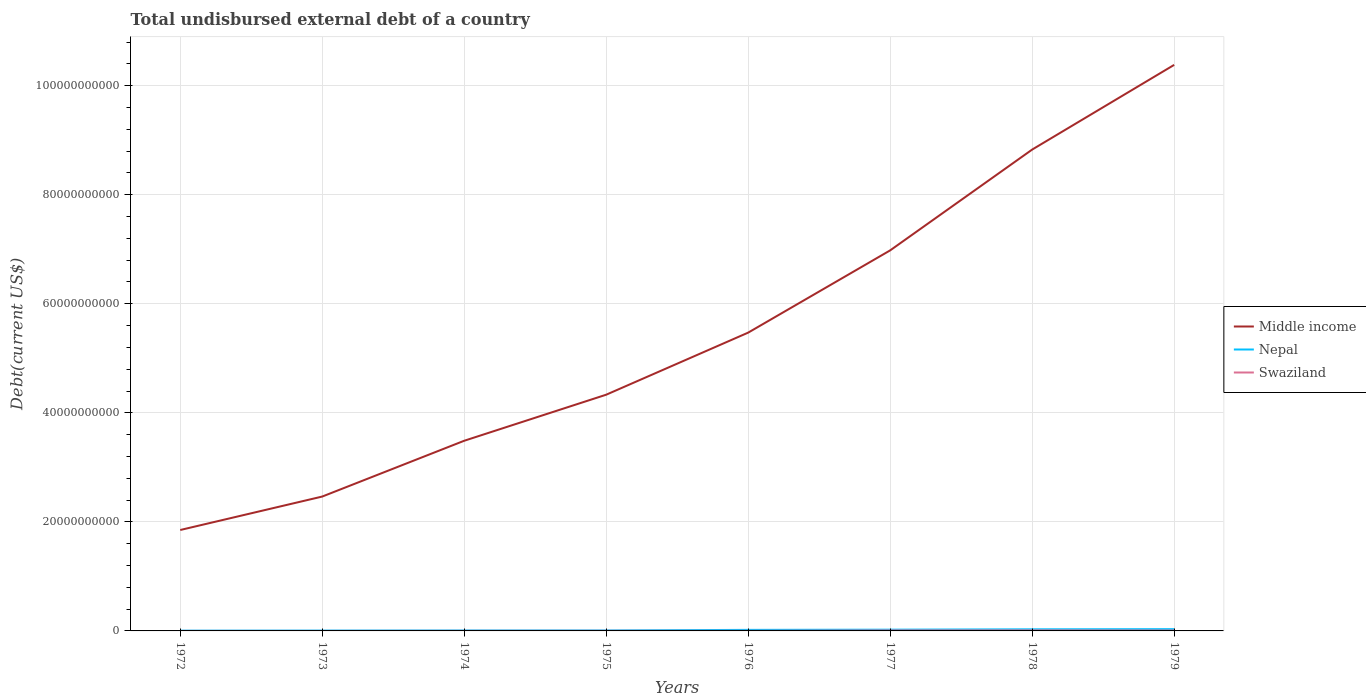Across all years, what is the maximum total undisbursed external debt in Middle income?
Give a very brief answer. 1.85e+1. What is the total total undisbursed external debt in Swaziland in the graph?
Your answer should be very brief. -7.01e+07. What is the difference between the highest and the second highest total undisbursed external debt in Nepal?
Keep it short and to the point. 2.76e+08. What is the difference between the highest and the lowest total undisbursed external debt in Middle income?
Ensure brevity in your answer.  3. Is the total undisbursed external debt in Swaziland strictly greater than the total undisbursed external debt in Nepal over the years?
Your answer should be compact. Yes. How many lines are there?
Give a very brief answer. 3. What is the difference between two consecutive major ticks on the Y-axis?
Your answer should be compact. 2.00e+1. Does the graph contain any zero values?
Ensure brevity in your answer.  No. Where does the legend appear in the graph?
Your response must be concise. Center right. How many legend labels are there?
Your answer should be compact. 3. What is the title of the graph?
Your response must be concise. Total undisbursed external debt of a country. Does "New Caledonia" appear as one of the legend labels in the graph?
Keep it short and to the point. No. What is the label or title of the Y-axis?
Offer a very short reply. Debt(current US$). What is the Debt(current US$) of Middle income in 1972?
Offer a very short reply. 1.85e+1. What is the Debt(current US$) of Nepal in 1972?
Offer a very short reply. 4.87e+07. What is the Debt(current US$) of Swaziland in 1972?
Your answer should be compact. 1.42e+06. What is the Debt(current US$) in Middle income in 1973?
Ensure brevity in your answer.  2.46e+1. What is the Debt(current US$) of Nepal in 1973?
Provide a succinct answer. 6.23e+07. What is the Debt(current US$) in Swaziland in 1973?
Provide a succinct answer. 2.10e+06. What is the Debt(current US$) of Middle income in 1974?
Your response must be concise. 3.49e+1. What is the Debt(current US$) in Nepal in 1974?
Give a very brief answer. 8.11e+07. What is the Debt(current US$) of Swaziland in 1974?
Keep it short and to the point. 1.30e+07. What is the Debt(current US$) in Middle income in 1975?
Your response must be concise. 4.33e+1. What is the Debt(current US$) in Nepal in 1975?
Your response must be concise. 8.62e+07. What is the Debt(current US$) in Swaziland in 1975?
Give a very brief answer. 2.20e+07. What is the Debt(current US$) of Middle income in 1976?
Your answer should be very brief. 5.47e+1. What is the Debt(current US$) in Nepal in 1976?
Make the answer very short. 1.92e+08. What is the Debt(current US$) in Swaziland in 1976?
Provide a succinct answer. 1.75e+07. What is the Debt(current US$) in Middle income in 1977?
Give a very brief answer. 6.98e+1. What is the Debt(current US$) in Nepal in 1977?
Provide a succinct answer. 2.28e+08. What is the Debt(current US$) in Swaziland in 1977?
Provide a succinct answer. 8.31e+07. What is the Debt(current US$) of Middle income in 1978?
Provide a short and direct response. 8.83e+1. What is the Debt(current US$) of Nepal in 1978?
Make the answer very short. 2.94e+08. What is the Debt(current US$) of Swaziland in 1978?
Your answer should be compact. 9.63e+07. What is the Debt(current US$) in Middle income in 1979?
Your response must be concise. 1.04e+11. What is the Debt(current US$) of Nepal in 1979?
Offer a very short reply. 3.24e+08. What is the Debt(current US$) in Swaziland in 1979?
Your response must be concise. 7.16e+07. Across all years, what is the maximum Debt(current US$) of Middle income?
Give a very brief answer. 1.04e+11. Across all years, what is the maximum Debt(current US$) in Nepal?
Keep it short and to the point. 3.24e+08. Across all years, what is the maximum Debt(current US$) in Swaziland?
Make the answer very short. 9.63e+07. Across all years, what is the minimum Debt(current US$) of Middle income?
Provide a succinct answer. 1.85e+1. Across all years, what is the minimum Debt(current US$) in Nepal?
Offer a terse response. 4.87e+07. Across all years, what is the minimum Debt(current US$) in Swaziland?
Offer a terse response. 1.42e+06. What is the total Debt(current US$) in Middle income in the graph?
Make the answer very short. 4.38e+11. What is the total Debt(current US$) in Nepal in the graph?
Provide a short and direct response. 1.32e+09. What is the total Debt(current US$) of Swaziland in the graph?
Your response must be concise. 3.07e+08. What is the difference between the Debt(current US$) in Middle income in 1972 and that in 1973?
Keep it short and to the point. -6.13e+09. What is the difference between the Debt(current US$) in Nepal in 1972 and that in 1973?
Offer a terse response. -1.37e+07. What is the difference between the Debt(current US$) of Swaziland in 1972 and that in 1973?
Your response must be concise. -6.87e+05. What is the difference between the Debt(current US$) of Middle income in 1972 and that in 1974?
Make the answer very short. -1.64e+1. What is the difference between the Debt(current US$) of Nepal in 1972 and that in 1974?
Your response must be concise. -3.25e+07. What is the difference between the Debt(current US$) in Swaziland in 1972 and that in 1974?
Offer a very short reply. -1.16e+07. What is the difference between the Debt(current US$) of Middle income in 1972 and that in 1975?
Your response must be concise. -2.48e+1. What is the difference between the Debt(current US$) of Nepal in 1972 and that in 1975?
Give a very brief answer. -3.76e+07. What is the difference between the Debt(current US$) of Swaziland in 1972 and that in 1975?
Ensure brevity in your answer.  -2.06e+07. What is the difference between the Debt(current US$) of Middle income in 1972 and that in 1976?
Give a very brief answer. -3.62e+1. What is the difference between the Debt(current US$) of Nepal in 1972 and that in 1976?
Offer a very short reply. -1.44e+08. What is the difference between the Debt(current US$) of Swaziland in 1972 and that in 1976?
Provide a succinct answer. -1.61e+07. What is the difference between the Debt(current US$) of Middle income in 1972 and that in 1977?
Offer a very short reply. -5.13e+1. What is the difference between the Debt(current US$) in Nepal in 1972 and that in 1977?
Your response must be concise. -1.80e+08. What is the difference between the Debt(current US$) in Swaziland in 1972 and that in 1977?
Make the answer very short. -8.17e+07. What is the difference between the Debt(current US$) of Middle income in 1972 and that in 1978?
Your answer should be very brief. -6.98e+1. What is the difference between the Debt(current US$) in Nepal in 1972 and that in 1978?
Your answer should be very brief. -2.46e+08. What is the difference between the Debt(current US$) in Swaziland in 1972 and that in 1978?
Your answer should be compact. -9.49e+07. What is the difference between the Debt(current US$) in Middle income in 1972 and that in 1979?
Give a very brief answer. -8.53e+1. What is the difference between the Debt(current US$) in Nepal in 1972 and that in 1979?
Ensure brevity in your answer.  -2.76e+08. What is the difference between the Debt(current US$) in Swaziland in 1972 and that in 1979?
Your answer should be very brief. -7.02e+07. What is the difference between the Debt(current US$) of Middle income in 1973 and that in 1974?
Keep it short and to the point. -1.02e+1. What is the difference between the Debt(current US$) in Nepal in 1973 and that in 1974?
Give a very brief answer. -1.88e+07. What is the difference between the Debt(current US$) in Swaziland in 1973 and that in 1974?
Ensure brevity in your answer.  -1.09e+07. What is the difference between the Debt(current US$) in Middle income in 1973 and that in 1975?
Give a very brief answer. -1.87e+1. What is the difference between the Debt(current US$) in Nepal in 1973 and that in 1975?
Your response must be concise. -2.39e+07. What is the difference between the Debt(current US$) of Swaziland in 1973 and that in 1975?
Offer a very short reply. -1.99e+07. What is the difference between the Debt(current US$) of Middle income in 1973 and that in 1976?
Offer a terse response. -3.01e+1. What is the difference between the Debt(current US$) in Nepal in 1973 and that in 1976?
Provide a succinct answer. -1.30e+08. What is the difference between the Debt(current US$) in Swaziland in 1973 and that in 1976?
Give a very brief answer. -1.54e+07. What is the difference between the Debt(current US$) of Middle income in 1973 and that in 1977?
Give a very brief answer. -4.52e+1. What is the difference between the Debt(current US$) of Nepal in 1973 and that in 1977?
Give a very brief answer. -1.66e+08. What is the difference between the Debt(current US$) of Swaziland in 1973 and that in 1977?
Offer a terse response. -8.10e+07. What is the difference between the Debt(current US$) in Middle income in 1973 and that in 1978?
Your answer should be compact. -6.36e+1. What is the difference between the Debt(current US$) of Nepal in 1973 and that in 1978?
Your answer should be very brief. -2.32e+08. What is the difference between the Debt(current US$) in Swaziland in 1973 and that in 1978?
Ensure brevity in your answer.  -9.42e+07. What is the difference between the Debt(current US$) in Middle income in 1973 and that in 1979?
Provide a short and direct response. -7.92e+1. What is the difference between the Debt(current US$) in Nepal in 1973 and that in 1979?
Keep it short and to the point. -2.62e+08. What is the difference between the Debt(current US$) of Swaziland in 1973 and that in 1979?
Make the answer very short. -6.95e+07. What is the difference between the Debt(current US$) in Middle income in 1974 and that in 1975?
Provide a short and direct response. -8.45e+09. What is the difference between the Debt(current US$) in Nepal in 1974 and that in 1975?
Give a very brief answer. -5.09e+06. What is the difference between the Debt(current US$) of Swaziland in 1974 and that in 1975?
Offer a terse response. -8.95e+06. What is the difference between the Debt(current US$) of Middle income in 1974 and that in 1976?
Give a very brief answer. -1.98e+1. What is the difference between the Debt(current US$) of Nepal in 1974 and that in 1976?
Your answer should be compact. -1.11e+08. What is the difference between the Debt(current US$) of Swaziland in 1974 and that in 1976?
Offer a terse response. -4.43e+06. What is the difference between the Debt(current US$) in Middle income in 1974 and that in 1977?
Ensure brevity in your answer.  -3.49e+1. What is the difference between the Debt(current US$) in Nepal in 1974 and that in 1977?
Offer a terse response. -1.47e+08. What is the difference between the Debt(current US$) in Swaziland in 1974 and that in 1977?
Keep it short and to the point. -7.01e+07. What is the difference between the Debt(current US$) in Middle income in 1974 and that in 1978?
Give a very brief answer. -5.34e+1. What is the difference between the Debt(current US$) in Nepal in 1974 and that in 1978?
Offer a very short reply. -2.13e+08. What is the difference between the Debt(current US$) in Swaziland in 1974 and that in 1978?
Give a very brief answer. -8.33e+07. What is the difference between the Debt(current US$) of Middle income in 1974 and that in 1979?
Provide a succinct answer. -6.89e+1. What is the difference between the Debt(current US$) in Nepal in 1974 and that in 1979?
Provide a succinct answer. -2.43e+08. What is the difference between the Debt(current US$) in Swaziland in 1974 and that in 1979?
Make the answer very short. -5.86e+07. What is the difference between the Debt(current US$) in Middle income in 1975 and that in 1976?
Your response must be concise. -1.14e+1. What is the difference between the Debt(current US$) in Nepal in 1975 and that in 1976?
Give a very brief answer. -1.06e+08. What is the difference between the Debt(current US$) of Swaziland in 1975 and that in 1976?
Offer a very short reply. 4.52e+06. What is the difference between the Debt(current US$) of Middle income in 1975 and that in 1977?
Offer a very short reply. -2.65e+1. What is the difference between the Debt(current US$) of Nepal in 1975 and that in 1977?
Give a very brief answer. -1.42e+08. What is the difference between the Debt(current US$) in Swaziland in 1975 and that in 1977?
Provide a succinct answer. -6.11e+07. What is the difference between the Debt(current US$) in Middle income in 1975 and that in 1978?
Offer a terse response. -4.50e+1. What is the difference between the Debt(current US$) of Nepal in 1975 and that in 1978?
Keep it short and to the point. -2.08e+08. What is the difference between the Debt(current US$) in Swaziland in 1975 and that in 1978?
Your response must be concise. -7.43e+07. What is the difference between the Debt(current US$) in Middle income in 1975 and that in 1979?
Provide a succinct answer. -6.05e+1. What is the difference between the Debt(current US$) of Nepal in 1975 and that in 1979?
Offer a terse response. -2.38e+08. What is the difference between the Debt(current US$) of Swaziland in 1975 and that in 1979?
Provide a succinct answer. -4.96e+07. What is the difference between the Debt(current US$) in Middle income in 1976 and that in 1977?
Give a very brief answer. -1.51e+1. What is the difference between the Debt(current US$) of Nepal in 1976 and that in 1977?
Offer a terse response. -3.63e+07. What is the difference between the Debt(current US$) in Swaziland in 1976 and that in 1977?
Provide a short and direct response. -6.56e+07. What is the difference between the Debt(current US$) of Middle income in 1976 and that in 1978?
Keep it short and to the point. -3.36e+1. What is the difference between the Debt(current US$) of Nepal in 1976 and that in 1978?
Your answer should be compact. -1.02e+08. What is the difference between the Debt(current US$) in Swaziland in 1976 and that in 1978?
Ensure brevity in your answer.  -7.88e+07. What is the difference between the Debt(current US$) in Middle income in 1976 and that in 1979?
Your answer should be very brief. -4.91e+1. What is the difference between the Debt(current US$) of Nepal in 1976 and that in 1979?
Give a very brief answer. -1.32e+08. What is the difference between the Debt(current US$) of Swaziland in 1976 and that in 1979?
Your response must be concise. -5.42e+07. What is the difference between the Debt(current US$) of Middle income in 1977 and that in 1978?
Ensure brevity in your answer.  -1.85e+1. What is the difference between the Debt(current US$) of Nepal in 1977 and that in 1978?
Give a very brief answer. -6.57e+07. What is the difference between the Debt(current US$) of Swaziland in 1977 and that in 1978?
Offer a very short reply. -1.32e+07. What is the difference between the Debt(current US$) of Middle income in 1977 and that in 1979?
Offer a very short reply. -3.40e+1. What is the difference between the Debt(current US$) in Nepal in 1977 and that in 1979?
Keep it short and to the point. -9.57e+07. What is the difference between the Debt(current US$) in Swaziland in 1977 and that in 1979?
Your response must be concise. 1.15e+07. What is the difference between the Debt(current US$) of Middle income in 1978 and that in 1979?
Give a very brief answer. -1.55e+1. What is the difference between the Debt(current US$) in Nepal in 1978 and that in 1979?
Give a very brief answer. -3.00e+07. What is the difference between the Debt(current US$) in Swaziland in 1978 and that in 1979?
Provide a succinct answer. 2.47e+07. What is the difference between the Debt(current US$) of Middle income in 1972 and the Debt(current US$) of Nepal in 1973?
Make the answer very short. 1.84e+1. What is the difference between the Debt(current US$) in Middle income in 1972 and the Debt(current US$) in Swaziland in 1973?
Provide a short and direct response. 1.85e+1. What is the difference between the Debt(current US$) of Nepal in 1972 and the Debt(current US$) of Swaziland in 1973?
Your answer should be very brief. 4.66e+07. What is the difference between the Debt(current US$) in Middle income in 1972 and the Debt(current US$) in Nepal in 1974?
Your answer should be compact. 1.84e+1. What is the difference between the Debt(current US$) of Middle income in 1972 and the Debt(current US$) of Swaziland in 1974?
Your answer should be very brief. 1.85e+1. What is the difference between the Debt(current US$) in Nepal in 1972 and the Debt(current US$) in Swaziland in 1974?
Your answer should be compact. 3.56e+07. What is the difference between the Debt(current US$) in Middle income in 1972 and the Debt(current US$) in Nepal in 1975?
Keep it short and to the point. 1.84e+1. What is the difference between the Debt(current US$) in Middle income in 1972 and the Debt(current US$) in Swaziland in 1975?
Give a very brief answer. 1.85e+1. What is the difference between the Debt(current US$) in Nepal in 1972 and the Debt(current US$) in Swaziland in 1975?
Your response must be concise. 2.67e+07. What is the difference between the Debt(current US$) of Middle income in 1972 and the Debt(current US$) of Nepal in 1976?
Provide a succinct answer. 1.83e+1. What is the difference between the Debt(current US$) of Middle income in 1972 and the Debt(current US$) of Swaziland in 1976?
Provide a succinct answer. 1.85e+1. What is the difference between the Debt(current US$) in Nepal in 1972 and the Debt(current US$) in Swaziland in 1976?
Provide a succinct answer. 3.12e+07. What is the difference between the Debt(current US$) of Middle income in 1972 and the Debt(current US$) of Nepal in 1977?
Provide a short and direct response. 1.83e+1. What is the difference between the Debt(current US$) of Middle income in 1972 and the Debt(current US$) of Swaziland in 1977?
Your response must be concise. 1.84e+1. What is the difference between the Debt(current US$) of Nepal in 1972 and the Debt(current US$) of Swaziland in 1977?
Your answer should be very brief. -3.44e+07. What is the difference between the Debt(current US$) of Middle income in 1972 and the Debt(current US$) of Nepal in 1978?
Give a very brief answer. 1.82e+1. What is the difference between the Debt(current US$) of Middle income in 1972 and the Debt(current US$) of Swaziland in 1978?
Your response must be concise. 1.84e+1. What is the difference between the Debt(current US$) in Nepal in 1972 and the Debt(current US$) in Swaziland in 1978?
Offer a very short reply. -4.76e+07. What is the difference between the Debt(current US$) in Middle income in 1972 and the Debt(current US$) in Nepal in 1979?
Your answer should be very brief. 1.82e+1. What is the difference between the Debt(current US$) in Middle income in 1972 and the Debt(current US$) in Swaziland in 1979?
Your answer should be very brief. 1.84e+1. What is the difference between the Debt(current US$) of Nepal in 1972 and the Debt(current US$) of Swaziland in 1979?
Provide a succinct answer. -2.30e+07. What is the difference between the Debt(current US$) of Middle income in 1973 and the Debt(current US$) of Nepal in 1974?
Ensure brevity in your answer.  2.46e+1. What is the difference between the Debt(current US$) of Middle income in 1973 and the Debt(current US$) of Swaziland in 1974?
Provide a succinct answer. 2.46e+1. What is the difference between the Debt(current US$) in Nepal in 1973 and the Debt(current US$) in Swaziland in 1974?
Ensure brevity in your answer.  4.93e+07. What is the difference between the Debt(current US$) of Middle income in 1973 and the Debt(current US$) of Nepal in 1975?
Your answer should be compact. 2.46e+1. What is the difference between the Debt(current US$) of Middle income in 1973 and the Debt(current US$) of Swaziland in 1975?
Make the answer very short. 2.46e+1. What is the difference between the Debt(current US$) of Nepal in 1973 and the Debt(current US$) of Swaziland in 1975?
Offer a terse response. 4.04e+07. What is the difference between the Debt(current US$) of Middle income in 1973 and the Debt(current US$) of Nepal in 1976?
Ensure brevity in your answer.  2.44e+1. What is the difference between the Debt(current US$) in Middle income in 1973 and the Debt(current US$) in Swaziland in 1976?
Provide a short and direct response. 2.46e+1. What is the difference between the Debt(current US$) of Nepal in 1973 and the Debt(current US$) of Swaziland in 1976?
Offer a terse response. 4.49e+07. What is the difference between the Debt(current US$) in Middle income in 1973 and the Debt(current US$) in Nepal in 1977?
Keep it short and to the point. 2.44e+1. What is the difference between the Debt(current US$) in Middle income in 1973 and the Debt(current US$) in Swaziland in 1977?
Offer a very short reply. 2.46e+1. What is the difference between the Debt(current US$) of Nepal in 1973 and the Debt(current US$) of Swaziland in 1977?
Ensure brevity in your answer.  -2.08e+07. What is the difference between the Debt(current US$) of Middle income in 1973 and the Debt(current US$) of Nepal in 1978?
Your answer should be very brief. 2.43e+1. What is the difference between the Debt(current US$) of Middle income in 1973 and the Debt(current US$) of Swaziland in 1978?
Make the answer very short. 2.45e+1. What is the difference between the Debt(current US$) of Nepal in 1973 and the Debt(current US$) of Swaziland in 1978?
Provide a succinct answer. -3.40e+07. What is the difference between the Debt(current US$) in Middle income in 1973 and the Debt(current US$) in Nepal in 1979?
Your response must be concise. 2.43e+1. What is the difference between the Debt(current US$) in Middle income in 1973 and the Debt(current US$) in Swaziland in 1979?
Keep it short and to the point. 2.46e+1. What is the difference between the Debt(current US$) of Nepal in 1973 and the Debt(current US$) of Swaziland in 1979?
Provide a short and direct response. -9.28e+06. What is the difference between the Debt(current US$) of Middle income in 1974 and the Debt(current US$) of Nepal in 1975?
Make the answer very short. 3.48e+1. What is the difference between the Debt(current US$) in Middle income in 1974 and the Debt(current US$) in Swaziland in 1975?
Your response must be concise. 3.49e+1. What is the difference between the Debt(current US$) of Nepal in 1974 and the Debt(current US$) of Swaziland in 1975?
Provide a short and direct response. 5.92e+07. What is the difference between the Debt(current US$) in Middle income in 1974 and the Debt(current US$) in Nepal in 1976?
Provide a short and direct response. 3.47e+1. What is the difference between the Debt(current US$) of Middle income in 1974 and the Debt(current US$) of Swaziland in 1976?
Ensure brevity in your answer.  3.49e+1. What is the difference between the Debt(current US$) in Nepal in 1974 and the Debt(current US$) in Swaziland in 1976?
Your response must be concise. 6.37e+07. What is the difference between the Debt(current US$) of Middle income in 1974 and the Debt(current US$) of Nepal in 1977?
Provide a succinct answer. 3.46e+1. What is the difference between the Debt(current US$) of Middle income in 1974 and the Debt(current US$) of Swaziland in 1977?
Make the answer very short. 3.48e+1. What is the difference between the Debt(current US$) in Nepal in 1974 and the Debt(current US$) in Swaziland in 1977?
Keep it short and to the point. -1.96e+06. What is the difference between the Debt(current US$) of Middle income in 1974 and the Debt(current US$) of Nepal in 1978?
Provide a short and direct response. 3.46e+1. What is the difference between the Debt(current US$) in Middle income in 1974 and the Debt(current US$) in Swaziland in 1978?
Offer a terse response. 3.48e+1. What is the difference between the Debt(current US$) of Nepal in 1974 and the Debt(current US$) of Swaziland in 1978?
Your answer should be very brief. -1.52e+07. What is the difference between the Debt(current US$) of Middle income in 1974 and the Debt(current US$) of Nepal in 1979?
Keep it short and to the point. 3.46e+1. What is the difference between the Debt(current US$) of Middle income in 1974 and the Debt(current US$) of Swaziland in 1979?
Provide a succinct answer. 3.48e+1. What is the difference between the Debt(current US$) in Nepal in 1974 and the Debt(current US$) in Swaziland in 1979?
Provide a short and direct response. 9.51e+06. What is the difference between the Debt(current US$) in Middle income in 1975 and the Debt(current US$) in Nepal in 1976?
Your answer should be compact. 4.31e+1. What is the difference between the Debt(current US$) in Middle income in 1975 and the Debt(current US$) in Swaziland in 1976?
Offer a terse response. 4.33e+1. What is the difference between the Debt(current US$) in Nepal in 1975 and the Debt(current US$) in Swaziland in 1976?
Provide a short and direct response. 6.88e+07. What is the difference between the Debt(current US$) of Middle income in 1975 and the Debt(current US$) of Nepal in 1977?
Your answer should be compact. 4.31e+1. What is the difference between the Debt(current US$) of Middle income in 1975 and the Debt(current US$) of Swaziland in 1977?
Make the answer very short. 4.32e+1. What is the difference between the Debt(current US$) in Nepal in 1975 and the Debt(current US$) in Swaziland in 1977?
Provide a short and direct response. 3.12e+06. What is the difference between the Debt(current US$) of Middle income in 1975 and the Debt(current US$) of Nepal in 1978?
Give a very brief answer. 4.30e+1. What is the difference between the Debt(current US$) in Middle income in 1975 and the Debt(current US$) in Swaziland in 1978?
Offer a terse response. 4.32e+1. What is the difference between the Debt(current US$) in Nepal in 1975 and the Debt(current US$) in Swaziland in 1978?
Your response must be concise. -1.01e+07. What is the difference between the Debt(current US$) in Middle income in 1975 and the Debt(current US$) in Nepal in 1979?
Provide a succinct answer. 4.30e+1. What is the difference between the Debt(current US$) of Middle income in 1975 and the Debt(current US$) of Swaziland in 1979?
Your answer should be very brief. 4.33e+1. What is the difference between the Debt(current US$) in Nepal in 1975 and the Debt(current US$) in Swaziland in 1979?
Provide a short and direct response. 1.46e+07. What is the difference between the Debt(current US$) of Middle income in 1976 and the Debt(current US$) of Nepal in 1977?
Your answer should be very brief. 5.45e+1. What is the difference between the Debt(current US$) in Middle income in 1976 and the Debt(current US$) in Swaziland in 1977?
Your answer should be very brief. 5.46e+1. What is the difference between the Debt(current US$) of Nepal in 1976 and the Debt(current US$) of Swaziland in 1977?
Ensure brevity in your answer.  1.09e+08. What is the difference between the Debt(current US$) of Middle income in 1976 and the Debt(current US$) of Nepal in 1978?
Ensure brevity in your answer.  5.44e+1. What is the difference between the Debt(current US$) in Middle income in 1976 and the Debt(current US$) in Swaziland in 1978?
Offer a terse response. 5.46e+1. What is the difference between the Debt(current US$) in Nepal in 1976 and the Debt(current US$) in Swaziland in 1978?
Give a very brief answer. 9.59e+07. What is the difference between the Debt(current US$) of Middle income in 1976 and the Debt(current US$) of Nepal in 1979?
Provide a succinct answer. 5.44e+1. What is the difference between the Debt(current US$) in Middle income in 1976 and the Debt(current US$) in Swaziland in 1979?
Keep it short and to the point. 5.46e+1. What is the difference between the Debt(current US$) in Nepal in 1976 and the Debt(current US$) in Swaziland in 1979?
Offer a very short reply. 1.21e+08. What is the difference between the Debt(current US$) of Middle income in 1977 and the Debt(current US$) of Nepal in 1978?
Offer a terse response. 6.95e+1. What is the difference between the Debt(current US$) of Middle income in 1977 and the Debt(current US$) of Swaziland in 1978?
Offer a terse response. 6.97e+1. What is the difference between the Debt(current US$) in Nepal in 1977 and the Debt(current US$) in Swaziland in 1978?
Offer a terse response. 1.32e+08. What is the difference between the Debt(current US$) of Middle income in 1977 and the Debt(current US$) of Nepal in 1979?
Give a very brief answer. 6.95e+1. What is the difference between the Debt(current US$) in Middle income in 1977 and the Debt(current US$) in Swaziland in 1979?
Offer a very short reply. 6.97e+1. What is the difference between the Debt(current US$) in Nepal in 1977 and the Debt(current US$) in Swaziland in 1979?
Offer a terse response. 1.57e+08. What is the difference between the Debt(current US$) of Middle income in 1978 and the Debt(current US$) of Nepal in 1979?
Provide a succinct answer. 8.80e+1. What is the difference between the Debt(current US$) in Middle income in 1978 and the Debt(current US$) in Swaziland in 1979?
Give a very brief answer. 8.82e+1. What is the difference between the Debt(current US$) of Nepal in 1978 and the Debt(current US$) of Swaziland in 1979?
Ensure brevity in your answer.  2.23e+08. What is the average Debt(current US$) in Middle income per year?
Your answer should be very brief. 5.47e+1. What is the average Debt(current US$) in Nepal per year?
Provide a succinct answer. 1.65e+08. What is the average Debt(current US$) in Swaziland per year?
Give a very brief answer. 3.84e+07. In the year 1972, what is the difference between the Debt(current US$) in Middle income and Debt(current US$) in Nepal?
Your answer should be compact. 1.85e+1. In the year 1972, what is the difference between the Debt(current US$) in Middle income and Debt(current US$) in Swaziland?
Give a very brief answer. 1.85e+1. In the year 1972, what is the difference between the Debt(current US$) in Nepal and Debt(current US$) in Swaziland?
Offer a very short reply. 4.72e+07. In the year 1973, what is the difference between the Debt(current US$) of Middle income and Debt(current US$) of Nepal?
Give a very brief answer. 2.46e+1. In the year 1973, what is the difference between the Debt(current US$) in Middle income and Debt(current US$) in Swaziland?
Your answer should be compact. 2.46e+1. In the year 1973, what is the difference between the Debt(current US$) in Nepal and Debt(current US$) in Swaziland?
Your answer should be very brief. 6.02e+07. In the year 1974, what is the difference between the Debt(current US$) of Middle income and Debt(current US$) of Nepal?
Offer a terse response. 3.48e+1. In the year 1974, what is the difference between the Debt(current US$) in Middle income and Debt(current US$) in Swaziland?
Your answer should be very brief. 3.49e+1. In the year 1974, what is the difference between the Debt(current US$) in Nepal and Debt(current US$) in Swaziland?
Make the answer very short. 6.81e+07. In the year 1975, what is the difference between the Debt(current US$) in Middle income and Debt(current US$) in Nepal?
Give a very brief answer. 4.32e+1. In the year 1975, what is the difference between the Debt(current US$) in Middle income and Debt(current US$) in Swaziland?
Ensure brevity in your answer.  4.33e+1. In the year 1975, what is the difference between the Debt(current US$) of Nepal and Debt(current US$) of Swaziland?
Your answer should be compact. 6.42e+07. In the year 1976, what is the difference between the Debt(current US$) of Middle income and Debt(current US$) of Nepal?
Keep it short and to the point. 5.45e+1. In the year 1976, what is the difference between the Debt(current US$) in Middle income and Debt(current US$) in Swaziland?
Ensure brevity in your answer.  5.47e+1. In the year 1976, what is the difference between the Debt(current US$) of Nepal and Debt(current US$) of Swaziland?
Give a very brief answer. 1.75e+08. In the year 1977, what is the difference between the Debt(current US$) in Middle income and Debt(current US$) in Nepal?
Keep it short and to the point. 6.96e+1. In the year 1977, what is the difference between the Debt(current US$) of Middle income and Debt(current US$) of Swaziland?
Keep it short and to the point. 6.97e+1. In the year 1977, what is the difference between the Debt(current US$) of Nepal and Debt(current US$) of Swaziland?
Give a very brief answer. 1.45e+08. In the year 1978, what is the difference between the Debt(current US$) of Middle income and Debt(current US$) of Nepal?
Provide a short and direct response. 8.80e+1. In the year 1978, what is the difference between the Debt(current US$) of Middle income and Debt(current US$) of Swaziland?
Ensure brevity in your answer.  8.82e+1. In the year 1978, what is the difference between the Debt(current US$) of Nepal and Debt(current US$) of Swaziland?
Ensure brevity in your answer.  1.98e+08. In the year 1979, what is the difference between the Debt(current US$) in Middle income and Debt(current US$) in Nepal?
Give a very brief answer. 1.03e+11. In the year 1979, what is the difference between the Debt(current US$) in Middle income and Debt(current US$) in Swaziland?
Your answer should be compact. 1.04e+11. In the year 1979, what is the difference between the Debt(current US$) in Nepal and Debt(current US$) in Swaziland?
Your answer should be compact. 2.53e+08. What is the ratio of the Debt(current US$) in Middle income in 1972 to that in 1973?
Provide a short and direct response. 0.75. What is the ratio of the Debt(current US$) of Nepal in 1972 to that in 1973?
Give a very brief answer. 0.78. What is the ratio of the Debt(current US$) of Swaziland in 1972 to that in 1973?
Your response must be concise. 0.67. What is the ratio of the Debt(current US$) of Middle income in 1972 to that in 1974?
Ensure brevity in your answer.  0.53. What is the ratio of the Debt(current US$) of Nepal in 1972 to that in 1974?
Provide a succinct answer. 0.6. What is the ratio of the Debt(current US$) in Swaziland in 1972 to that in 1974?
Your answer should be compact. 0.11. What is the ratio of the Debt(current US$) of Middle income in 1972 to that in 1975?
Ensure brevity in your answer.  0.43. What is the ratio of the Debt(current US$) in Nepal in 1972 to that in 1975?
Your answer should be very brief. 0.56. What is the ratio of the Debt(current US$) in Swaziland in 1972 to that in 1975?
Make the answer very short. 0.06. What is the ratio of the Debt(current US$) of Middle income in 1972 to that in 1976?
Keep it short and to the point. 0.34. What is the ratio of the Debt(current US$) of Nepal in 1972 to that in 1976?
Provide a short and direct response. 0.25. What is the ratio of the Debt(current US$) in Swaziland in 1972 to that in 1976?
Give a very brief answer. 0.08. What is the ratio of the Debt(current US$) of Middle income in 1972 to that in 1977?
Provide a succinct answer. 0.27. What is the ratio of the Debt(current US$) of Nepal in 1972 to that in 1977?
Offer a very short reply. 0.21. What is the ratio of the Debt(current US$) of Swaziland in 1972 to that in 1977?
Your response must be concise. 0.02. What is the ratio of the Debt(current US$) in Middle income in 1972 to that in 1978?
Ensure brevity in your answer.  0.21. What is the ratio of the Debt(current US$) in Nepal in 1972 to that in 1978?
Provide a short and direct response. 0.17. What is the ratio of the Debt(current US$) of Swaziland in 1972 to that in 1978?
Ensure brevity in your answer.  0.01. What is the ratio of the Debt(current US$) in Middle income in 1972 to that in 1979?
Make the answer very short. 0.18. What is the ratio of the Debt(current US$) of Nepal in 1972 to that in 1979?
Make the answer very short. 0.15. What is the ratio of the Debt(current US$) in Swaziland in 1972 to that in 1979?
Keep it short and to the point. 0.02. What is the ratio of the Debt(current US$) in Middle income in 1973 to that in 1974?
Offer a terse response. 0.71. What is the ratio of the Debt(current US$) of Nepal in 1973 to that in 1974?
Your response must be concise. 0.77. What is the ratio of the Debt(current US$) in Swaziland in 1973 to that in 1974?
Give a very brief answer. 0.16. What is the ratio of the Debt(current US$) in Middle income in 1973 to that in 1975?
Your answer should be compact. 0.57. What is the ratio of the Debt(current US$) of Nepal in 1973 to that in 1975?
Offer a very short reply. 0.72. What is the ratio of the Debt(current US$) of Swaziland in 1973 to that in 1975?
Your response must be concise. 0.1. What is the ratio of the Debt(current US$) in Middle income in 1973 to that in 1976?
Make the answer very short. 0.45. What is the ratio of the Debt(current US$) in Nepal in 1973 to that in 1976?
Offer a terse response. 0.32. What is the ratio of the Debt(current US$) in Swaziland in 1973 to that in 1976?
Keep it short and to the point. 0.12. What is the ratio of the Debt(current US$) of Middle income in 1973 to that in 1977?
Your response must be concise. 0.35. What is the ratio of the Debt(current US$) in Nepal in 1973 to that in 1977?
Provide a succinct answer. 0.27. What is the ratio of the Debt(current US$) in Swaziland in 1973 to that in 1977?
Your answer should be very brief. 0.03. What is the ratio of the Debt(current US$) in Middle income in 1973 to that in 1978?
Provide a short and direct response. 0.28. What is the ratio of the Debt(current US$) in Nepal in 1973 to that in 1978?
Your response must be concise. 0.21. What is the ratio of the Debt(current US$) in Swaziland in 1973 to that in 1978?
Your answer should be compact. 0.02. What is the ratio of the Debt(current US$) in Middle income in 1973 to that in 1979?
Provide a short and direct response. 0.24. What is the ratio of the Debt(current US$) in Nepal in 1973 to that in 1979?
Provide a short and direct response. 0.19. What is the ratio of the Debt(current US$) of Swaziland in 1973 to that in 1979?
Make the answer very short. 0.03. What is the ratio of the Debt(current US$) of Middle income in 1974 to that in 1975?
Make the answer very short. 0.81. What is the ratio of the Debt(current US$) of Nepal in 1974 to that in 1975?
Offer a terse response. 0.94. What is the ratio of the Debt(current US$) in Swaziland in 1974 to that in 1975?
Keep it short and to the point. 0.59. What is the ratio of the Debt(current US$) of Middle income in 1974 to that in 1976?
Give a very brief answer. 0.64. What is the ratio of the Debt(current US$) of Nepal in 1974 to that in 1976?
Offer a terse response. 0.42. What is the ratio of the Debt(current US$) of Swaziland in 1974 to that in 1976?
Offer a very short reply. 0.75. What is the ratio of the Debt(current US$) of Middle income in 1974 to that in 1977?
Provide a short and direct response. 0.5. What is the ratio of the Debt(current US$) of Nepal in 1974 to that in 1977?
Ensure brevity in your answer.  0.36. What is the ratio of the Debt(current US$) of Swaziland in 1974 to that in 1977?
Offer a very short reply. 0.16. What is the ratio of the Debt(current US$) in Middle income in 1974 to that in 1978?
Your answer should be very brief. 0.4. What is the ratio of the Debt(current US$) of Nepal in 1974 to that in 1978?
Keep it short and to the point. 0.28. What is the ratio of the Debt(current US$) of Swaziland in 1974 to that in 1978?
Your response must be concise. 0.14. What is the ratio of the Debt(current US$) in Middle income in 1974 to that in 1979?
Ensure brevity in your answer.  0.34. What is the ratio of the Debt(current US$) in Nepal in 1974 to that in 1979?
Keep it short and to the point. 0.25. What is the ratio of the Debt(current US$) in Swaziland in 1974 to that in 1979?
Give a very brief answer. 0.18. What is the ratio of the Debt(current US$) of Middle income in 1975 to that in 1976?
Your answer should be compact. 0.79. What is the ratio of the Debt(current US$) in Nepal in 1975 to that in 1976?
Your answer should be compact. 0.45. What is the ratio of the Debt(current US$) in Swaziland in 1975 to that in 1976?
Provide a short and direct response. 1.26. What is the ratio of the Debt(current US$) of Middle income in 1975 to that in 1977?
Your response must be concise. 0.62. What is the ratio of the Debt(current US$) in Nepal in 1975 to that in 1977?
Provide a short and direct response. 0.38. What is the ratio of the Debt(current US$) in Swaziland in 1975 to that in 1977?
Your answer should be compact. 0.26. What is the ratio of the Debt(current US$) in Middle income in 1975 to that in 1978?
Offer a very short reply. 0.49. What is the ratio of the Debt(current US$) in Nepal in 1975 to that in 1978?
Keep it short and to the point. 0.29. What is the ratio of the Debt(current US$) in Swaziland in 1975 to that in 1978?
Provide a succinct answer. 0.23. What is the ratio of the Debt(current US$) of Middle income in 1975 to that in 1979?
Provide a short and direct response. 0.42. What is the ratio of the Debt(current US$) of Nepal in 1975 to that in 1979?
Provide a succinct answer. 0.27. What is the ratio of the Debt(current US$) in Swaziland in 1975 to that in 1979?
Your response must be concise. 0.31. What is the ratio of the Debt(current US$) in Middle income in 1976 to that in 1977?
Your answer should be very brief. 0.78. What is the ratio of the Debt(current US$) in Nepal in 1976 to that in 1977?
Provide a succinct answer. 0.84. What is the ratio of the Debt(current US$) of Swaziland in 1976 to that in 1977?
Your answer should be compact. 0.21. What is the ratio of the Debt(current US$) in Middle income in 1976 to that in 1978?
Make the answer very short. 0.62. What is the ratio of the Debt(current US$) in Nepal in 1976 to that in 1978?
Provide a succinct answer. 0.65. What is the ratio of the Debt(current US$) in Swaziland in 1976 to that in 1978?
Provide a succinct answer. 0.18. What is the ratio of the Debt(current US$) in Middle income in 1976 to that in 1979?
Give a very brief answer. 0.53. What is the ratio of the Debt(current US$) in Nepal in 1976 to that in 1979?
Provide a succinct answer. 0.59. What is the ratio of the Debt(current US$) of Swaziland in 1976 to that in 1979?
Your response must be concise. 0.24. What is the ratio of the Debt(current US$) in Middle income in 1977 to that in 1978?
Your answer should be compact. 0.79. What is the ratio of the Debt(current US$) of Nepal in 1977 to that in 1978?
Your answer should be compact. 0.78. What is the ratio of the Debt(current US$) of Swaziland in 1977 to that in 1978?
Make the answer very short. 0.86. What is the ratio of the Debt(current US$) of Middle income in 1977 to that in 1979?
Make the answer very short. 0.67. What is the ratio of the Debt(current US$) of Nepal in 1977 to that in 1979?
Make the answer very short. 0.7. What is the ratio of the Debt(current US$) of Swaziland in 1977 to that in 1979?
Make the answer very short. 1.16. What is the ratio of the Debt(current US$) of Middle income in 1978 to that in 1979?
Keep it short and to the point. 0.85. What is the ratio of the Debt(current US$) in Nepal in 1978 to that in 1979?
Give a very brief answer. 0.91. What is the ratio of the Debt(current US$) of Swaziland in 1978 to that in 1979?
Keep it short and to the point. 1.34. What is the difference between the highest and the second highest Debt(current US$) in Middle income?
Ensure brevity in your answer.  1.55e+1. What is the difference between the highest and the second highest Debt(current US$) in Nepal?
Make the answer very short. 3.00e+07. What is the difference between the highest and the second highest Debt(current US$) in Swaziland?
Offer a terse response. 1.32e+07. What is the difference between the highest and the lowest Debt(current US$) of Middle income?
Ensure brevity in your answer.  8.53e+1. What is the difference between the highest and the lowest Debt(current US$) of Nepal?
Provide a succinct answer. 2.76e+08. What is the difference between the highest and the lowest Debt(current US$) in Swaziland?
Make the answer very short. 9.49e+07. 